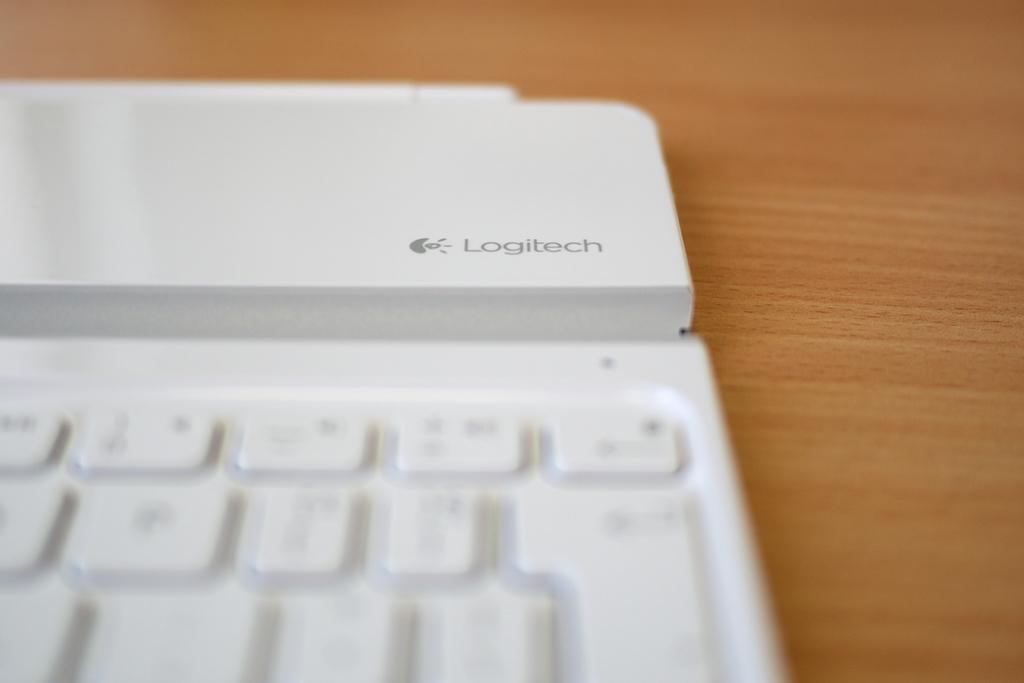What is the main object in the image? There is a keyboard in the image. Where is the keyboard located? The keyboard is placed on a table. What type of bun is being used to play the keyboard in the image? There is no bun present in the image, and the keyboard is not being played by any object or person. 